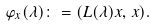<formula> <loc_0><loc_0><loc_500><loc_500>\varphi _ { x } ( \lambda ) \colon = ( L ( \lambda ) x , \, x ) .</formula> 